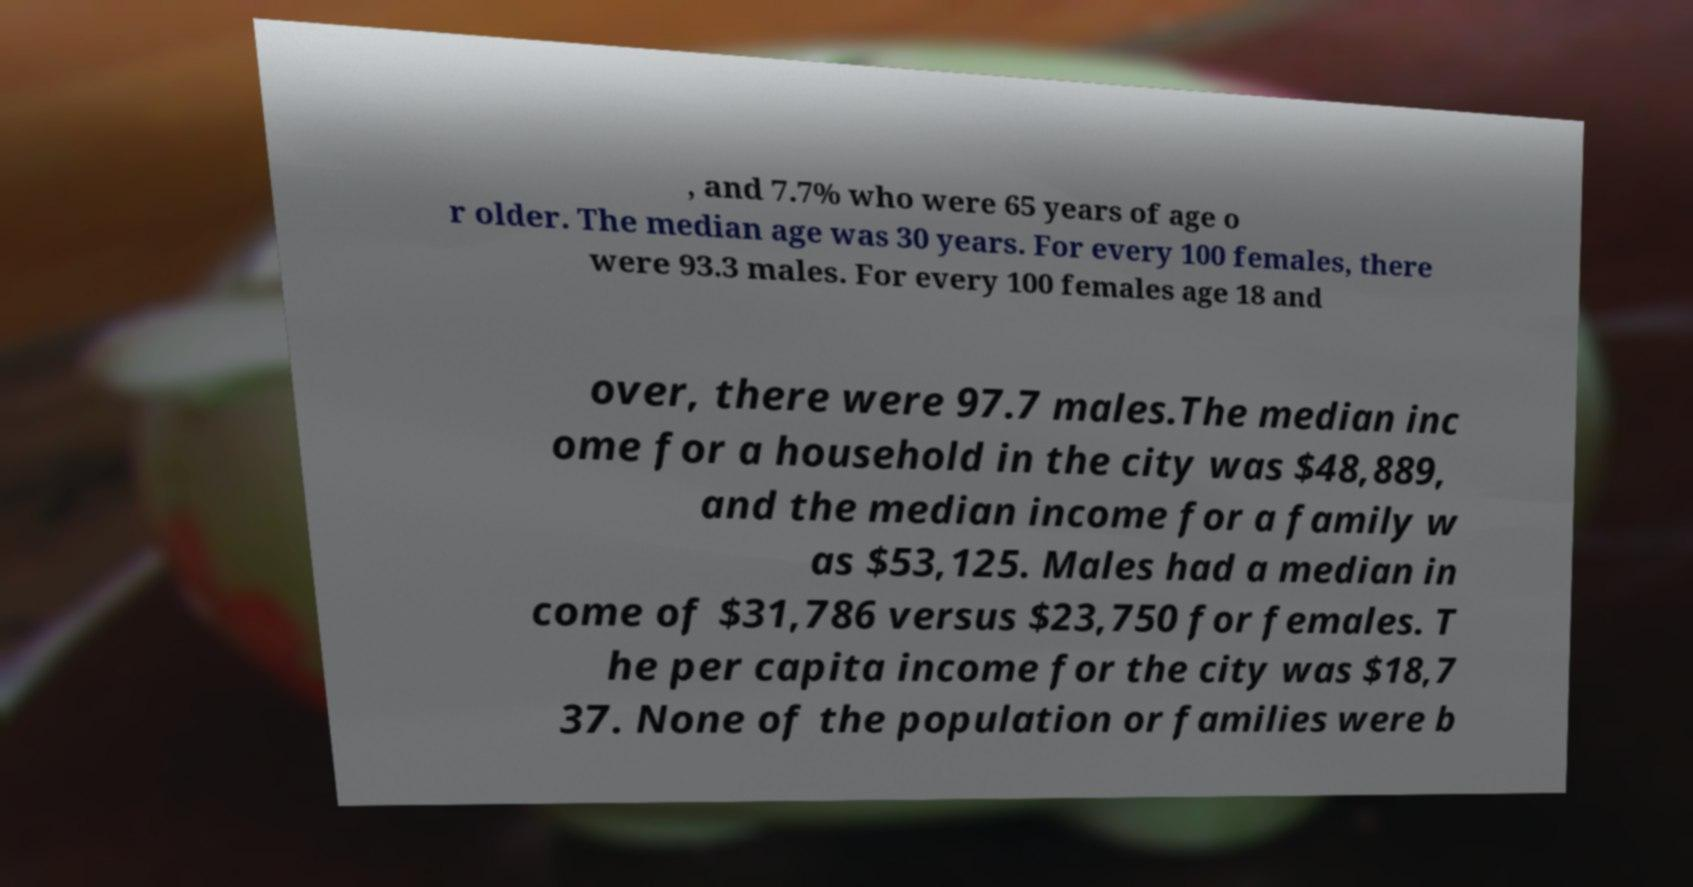Could you assist in decoding the text presented in this image and type it out clearly? , and 7.7% who were 65 years of age o r older. The median age was 30 years. For every 100 females, there were 93.3 males. For every 100 females age 18 and over, there were 97.7 males.The median inc ome for a household in the city was $48,889, and the median income for a family w as $53,125. Males had a median in come of $31,786 versus $23,750 for females. T he per capita income for the city was $18,7 37. None of the population or families were b 